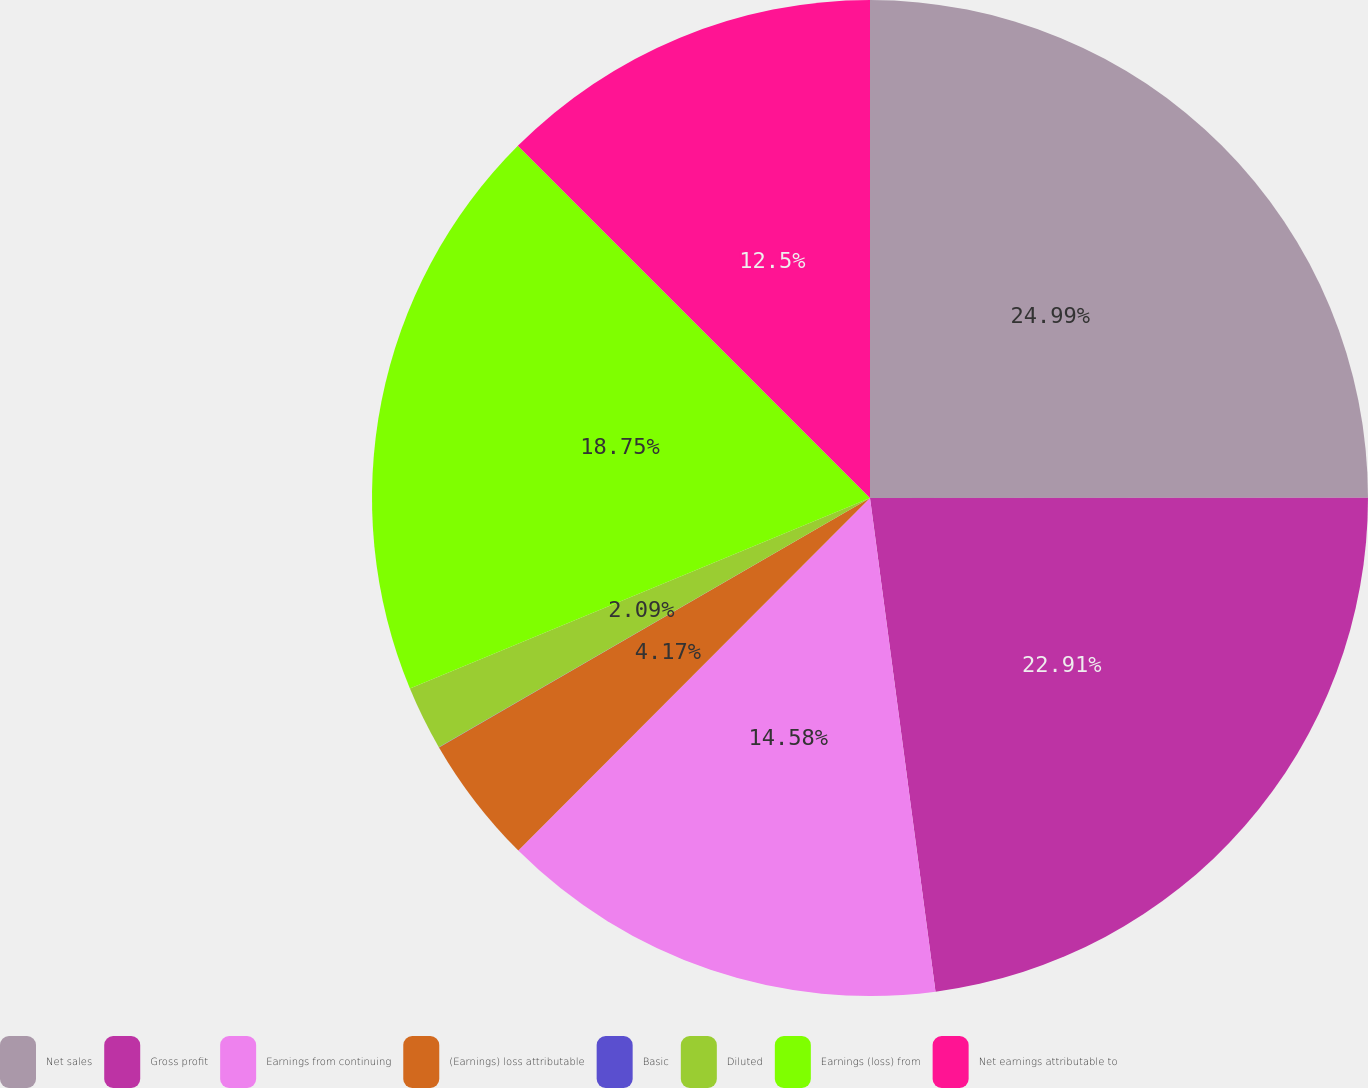<chart> <loc_0><loc_0><loc_500><loc_500><pie_chart><fcel>Net sales<fcel>Gross profit<fcel>Earnings from continuing<fcel>(Earnings) loss attributable<fcel>Basic<fcel>Diluted<fcel>Earnings (loss) from<fcel>Net earnings attributable to<nl><fcel>24.99%<fcel>22.91%<fcel>14.58%<fcel>4.17%<fcel>0.01%<fcel>2.09%<fcel>18.75%<fcel>12.5%<nl></chart> 